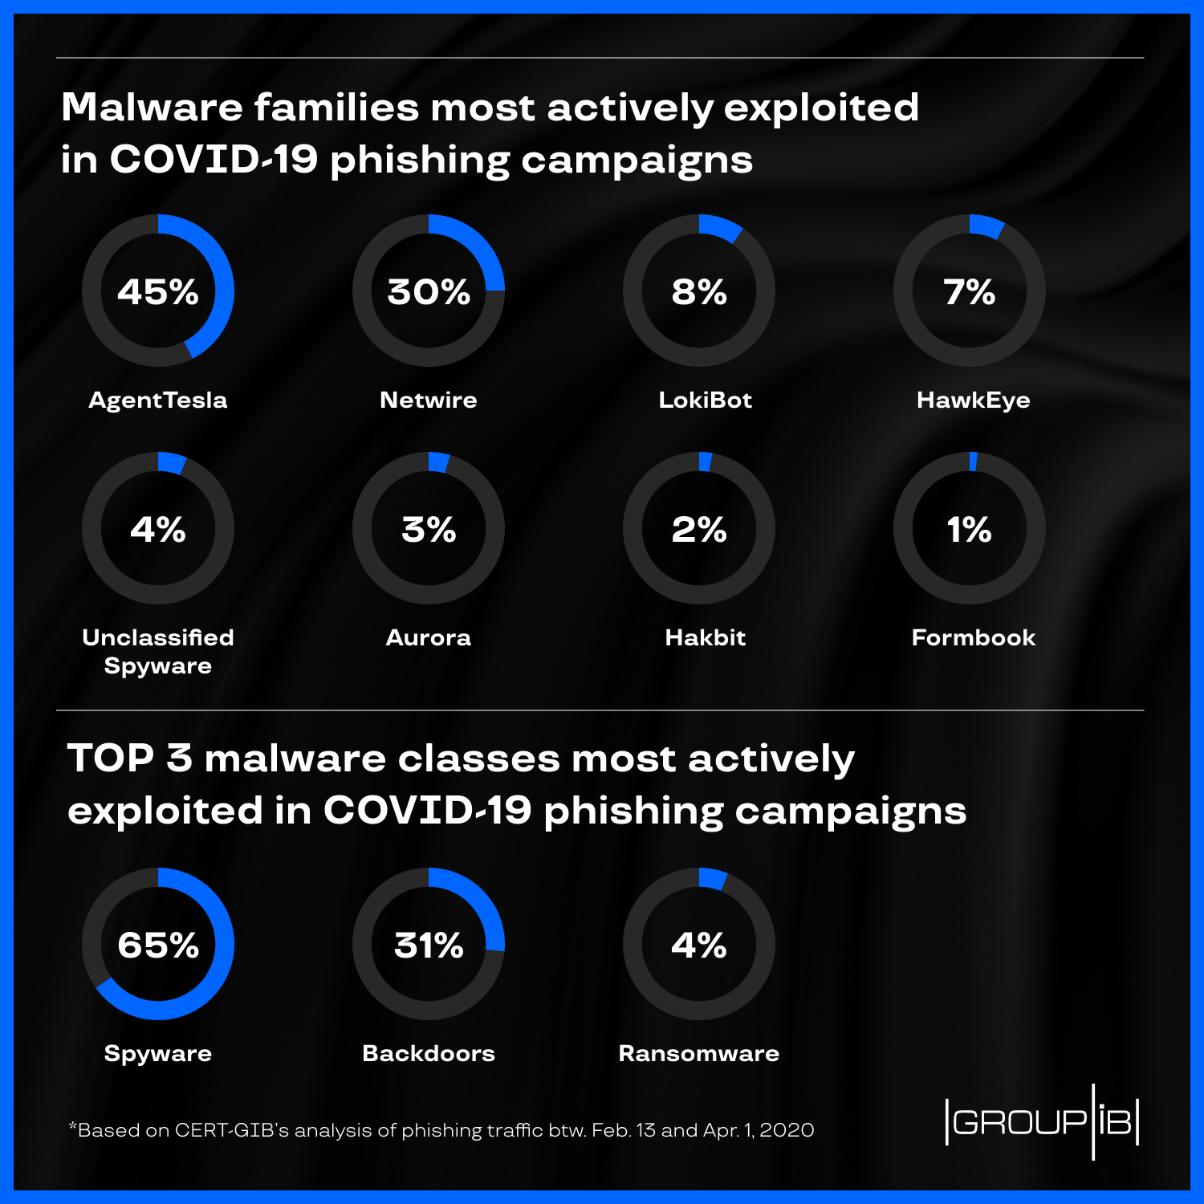Indicate a few pertinent items in this graphic. AgentTesla is the most actively exploited malware family in COVID-19 phishing campaigns. It is currently unknown which specific malware family is the least actively exploited in Covid-19 phishing campaigns. However, the Formbook family has not been widely utilized in these types of attacks. The second most commonly exploited malware family in COVID-19 phishing campaigns is Netwire. Spyware is the most actively exploited malware class in COVID-19 phishing campaigns. 